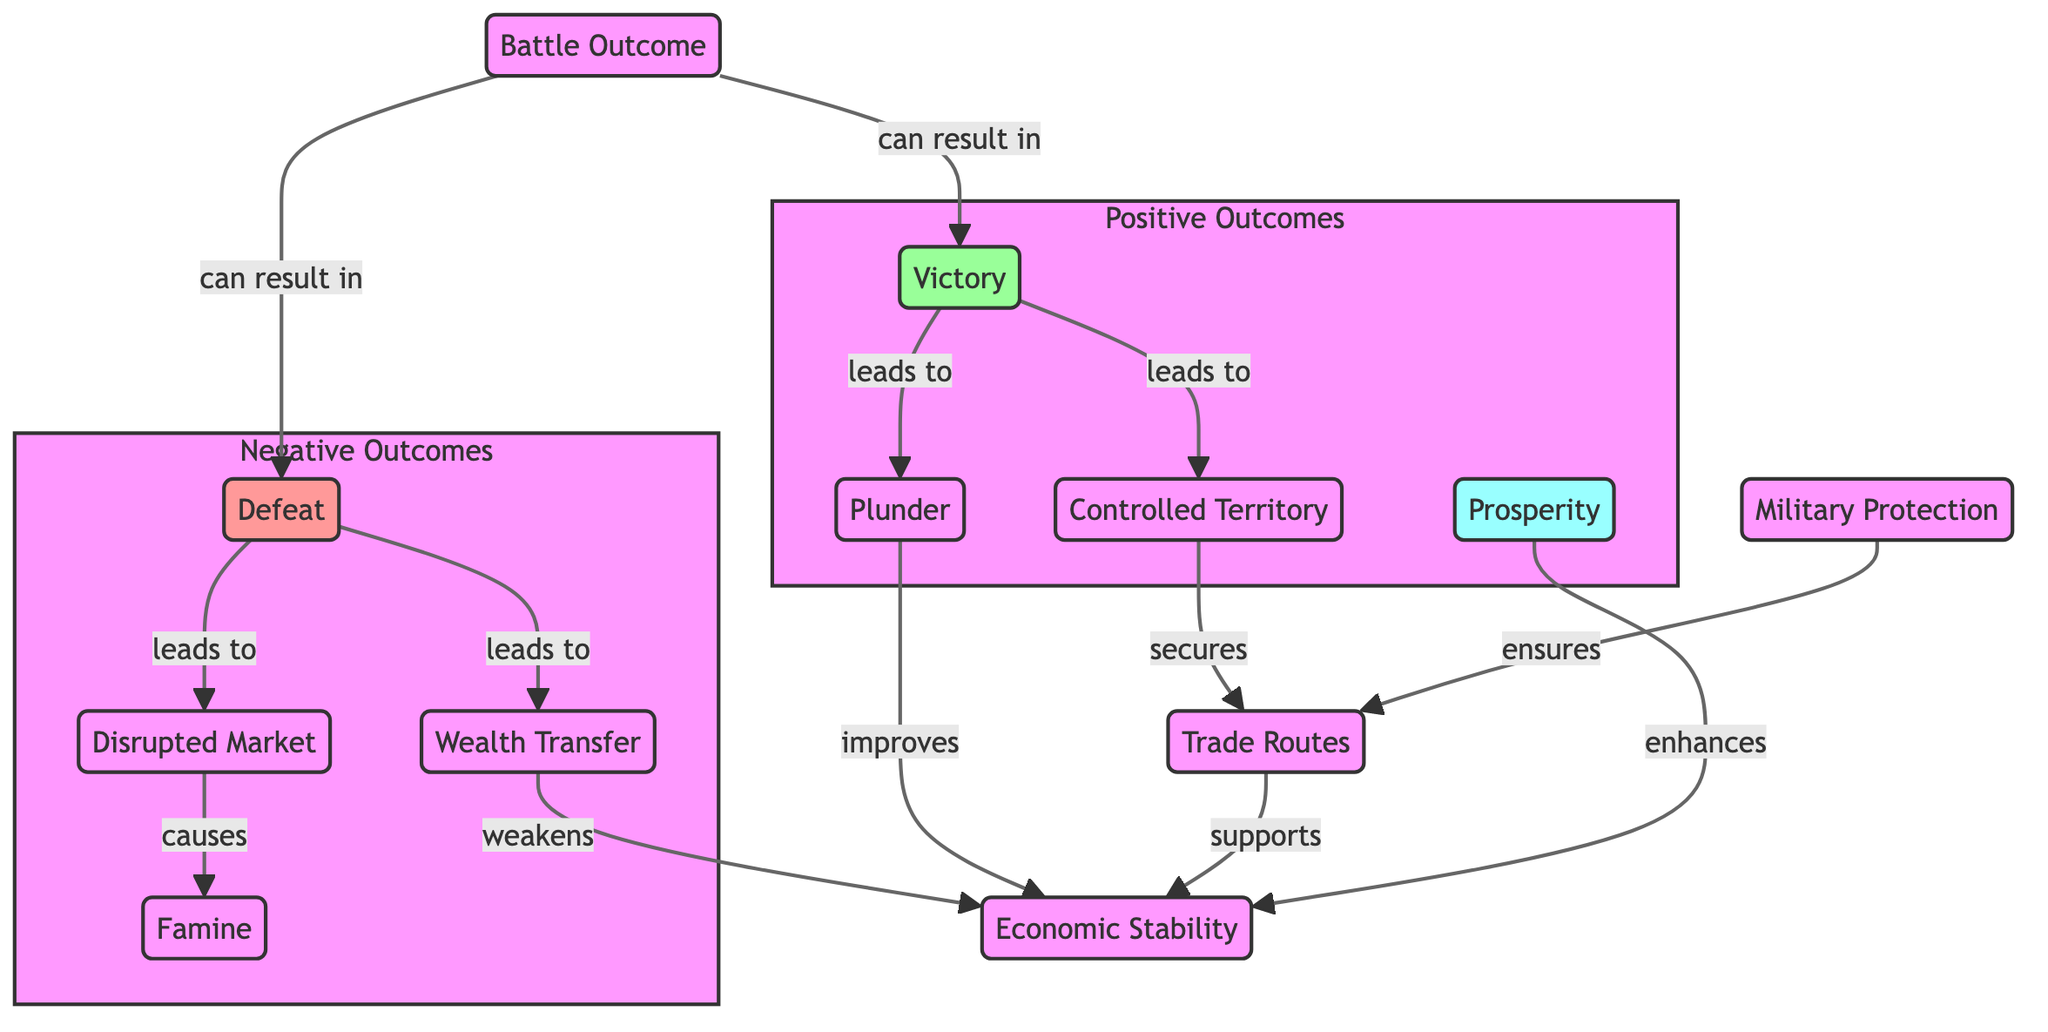What are the two possible outcomes of a battle? The diagram shows two branches from the "Battle Outcome" node: "Victory" and "Defeat".
Answer: Victory, Defeat What follows a victory in battle? From the "Victory" node, two direct outcomes are indicated: "Controlled Territory" and "Plunder".
Answer: Controlled Territory, Plunder What effect does a defeat have on the market? The "Defeat" node leads to "Disrupted Market", which is a direct consequence shown in the diagram.
Answer: Disrupted Market How is trade routes secured? The diagram indicates that "Controlled Territory" secures "Trade Routes", establishing a clear connection.
Answer: Controlled Territory What contributes to economic stability? The diagram lists multiple factors that support "Economic Stability", including "Trade Routes", "Military Protection", and "Prosperity".
Answer: Trade Routes, Military Protection, Prosperity What happens to economic stability due to wealth transfer? "Wealth Transfer" is indicated to weaken "Economic Stability" directly, as shown in the flow of the diagram.
Answer: Weakens How does plunder affect economic stability? The "Plunder" node leads to an improvement in "Economic Stability", indicating a positive outcome from plunder.
Answer: Improves What are the negative consequences of a disrupted market? The diagram shows that "Disrupted Market" causes "Famine", establishing a direct negative outcome.
Answer: Famine What links military protection and trade routes? From the diagram, "Military Protection" ensures "Trade Routes", illustrating a supportive relationship.
Answer: Ensures Name one positive outcome of a battle. The positive outcomes listed in the diagram include "Victory", "Controlled Territory", "Plunder", and "Prosperity".
Answer: Victory 